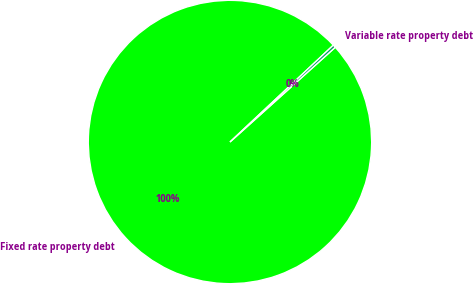Convert chart to OTSL. <chart><loc_0><loc_0><loc_500><loc_500><pie_chart><fcel>Fixed rate property debt<fcel>Variable rate property debt<nl><fcel>99.68%<fcel>0.32%<nl></chart> 